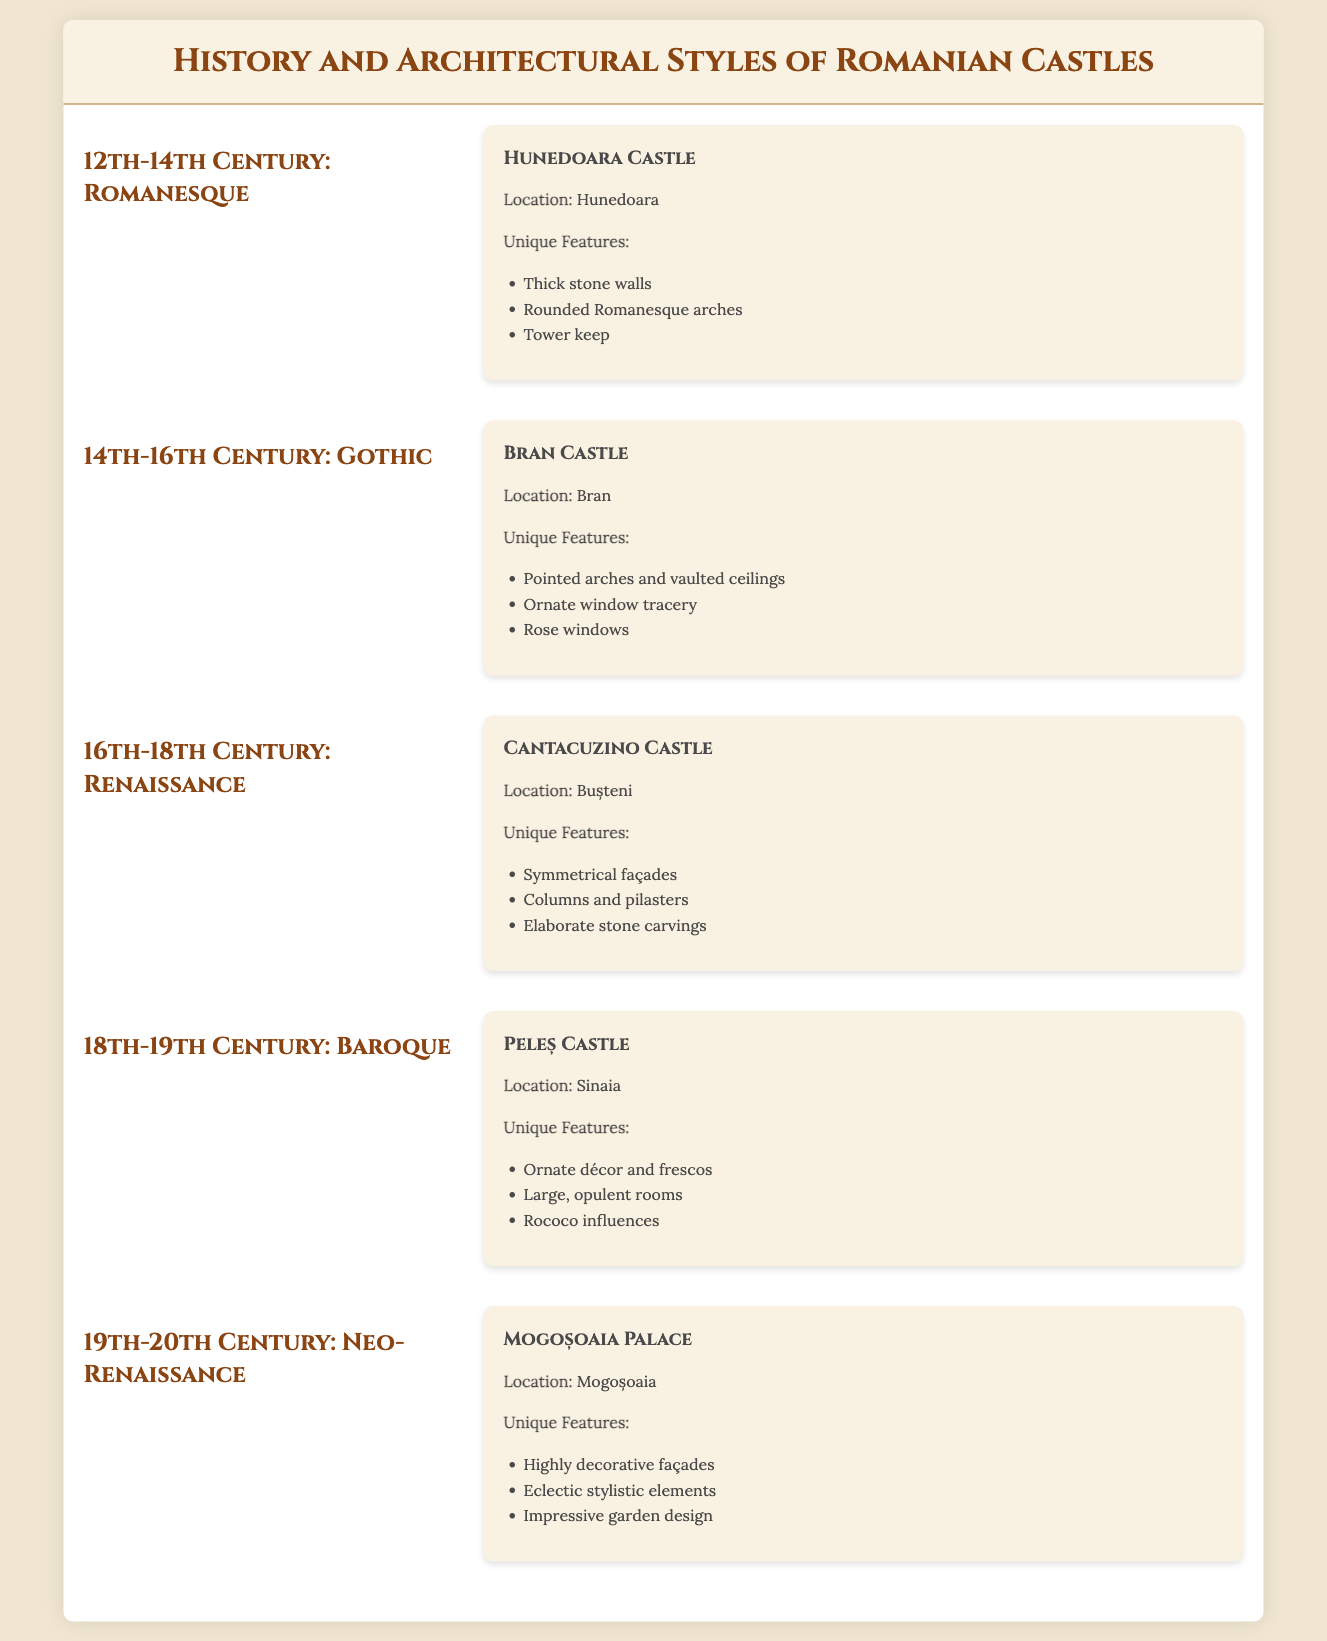What is the architectural style of Hunedoara Castle? The document states that Hunedoara Castle represents the Romanesque architectural style from the 12th-14th century.
Answer: Romanesque In which century was Bran Castle built? The timeline indicates that Bran Castle was built in the 14th-16th century, characterized by the Gothic architectural style.
Answer: 14th-16th Century What unique feature is associated with Cantacuzino Castle? Cantacuzino Castle is noted for its symmetrical façades in the Renaissance style.
Answer: Symmetrical façades Where is Peleș Castle located? The document lists Sinaia as the location of Peleș Castle, which showcases Baroque architecture.
Answer: Sinaia Which castle is an example of Neo-Renaissance architecture? The timeline notes that Mogoșoaia Palace is an example of Neo-Renaissance architecture.
Answer: Mogoșoaia Palace What type of arches does Bran Castle feature? Bran Castle features pointed arches as part of its Gothic design elements.
Answer: Pointed arches What is a defining characteristic of the Baroque style seen in Peleș Castle? The document highlights the ornate décor and frescos as a defining characteristic of the Baroque style in Peleș Castle.
Answer: Ornate décor Which castle has elaborate stone carvings? Cantacuzino Castle is specifically mentioned for its elaborate stone carvings in the Renaissance period.
Answer: Cantacuzino Castle 